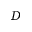<formula> <loc_0><loc_0><loc_500><loc_500>D</formula> 